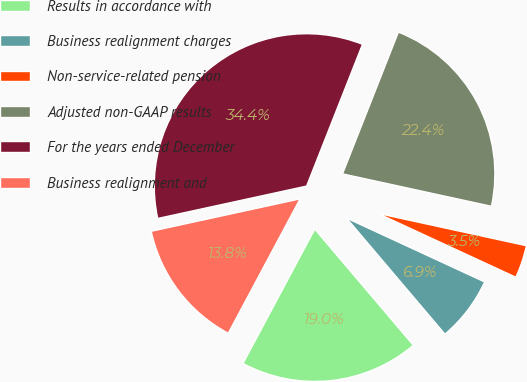Convert chart to OTSL. <chart><loc_0><loc_0><loc_500><loc_500><pie_chart><fcel>Results in accordance with<fcel>Business realignment charges<fcel>Non-service-related pension<fcel>Adjusted non-GAAP results<fcel>For the years ended December<fcel>Business realignment and<nl><fcel>19.01%<fcel>6.91%<fcel>3.48%<fcel>22.44%<fcel>34.39%<fcel>13.78%<nl></chart> 